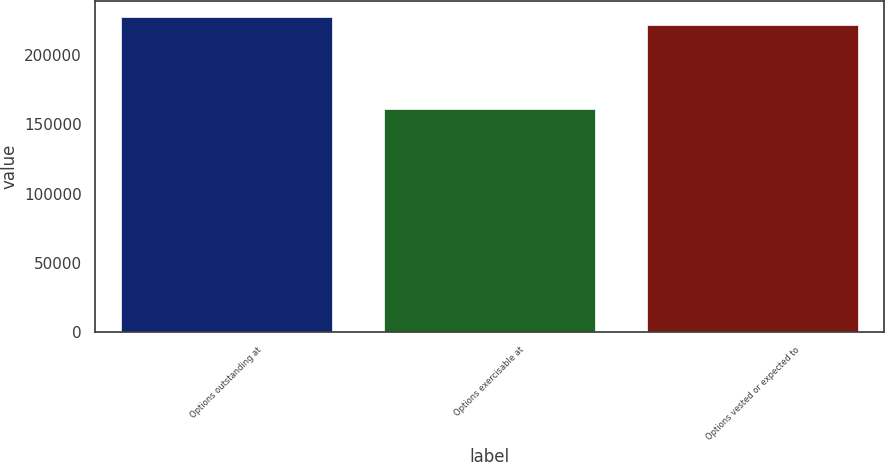Convert chart. <chart><loc_0><loc_0><loc_500><loc_500><bar_chart><fcel>Options outstanding at<fcel>Options exercisable at<fcel>Options vested or expected to<nl><fcel>227214<fcel>161135<fcel>221059<nl></chart> 